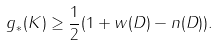<formula> <loc_0><loc_0><loc_500><loc_500>g _ { * } ( K ) \geq \frac { 1 } { 2 } ( 1 + w ( D ) - n ( D ) ) .</formula> 